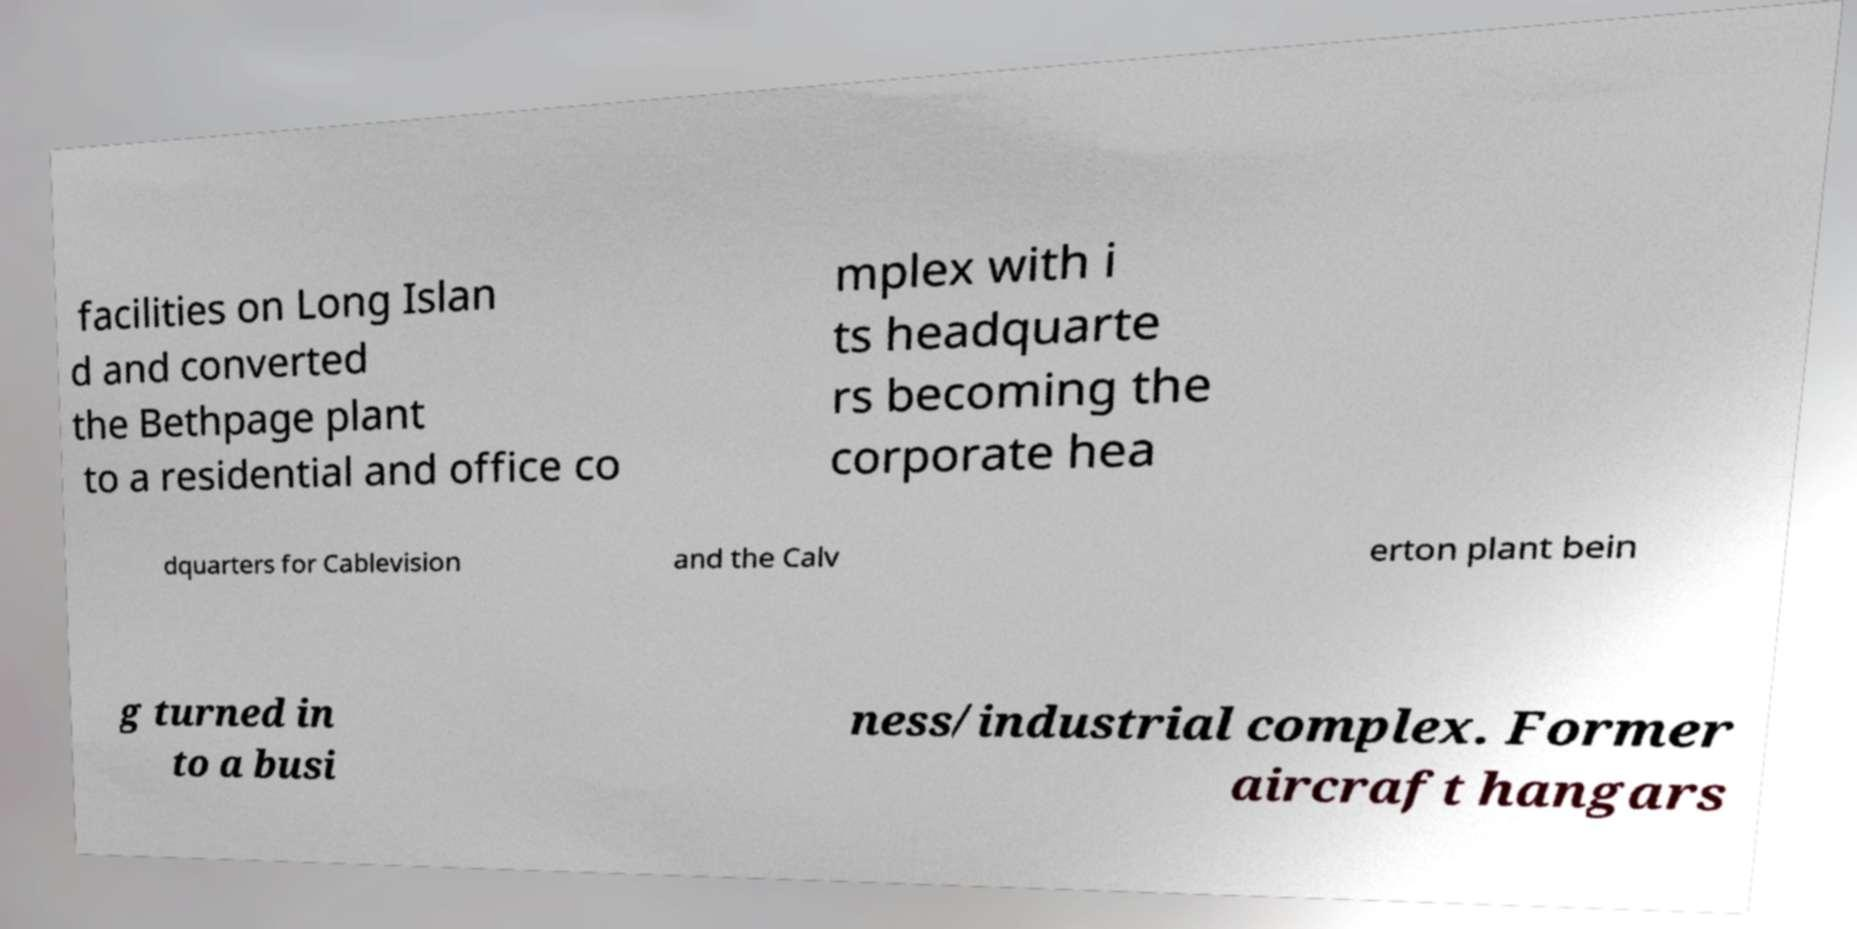Could you extract and type out the text from this image? facilities on Long Islan d and converted the Bethpage plant to a residential and office co mplex with i ts headquarte rs becoming the corporate hea dquarters for Cablevision and the Calv erton plant bein g turned in to a busi ness/industrial complex. Former aircraft hangars 